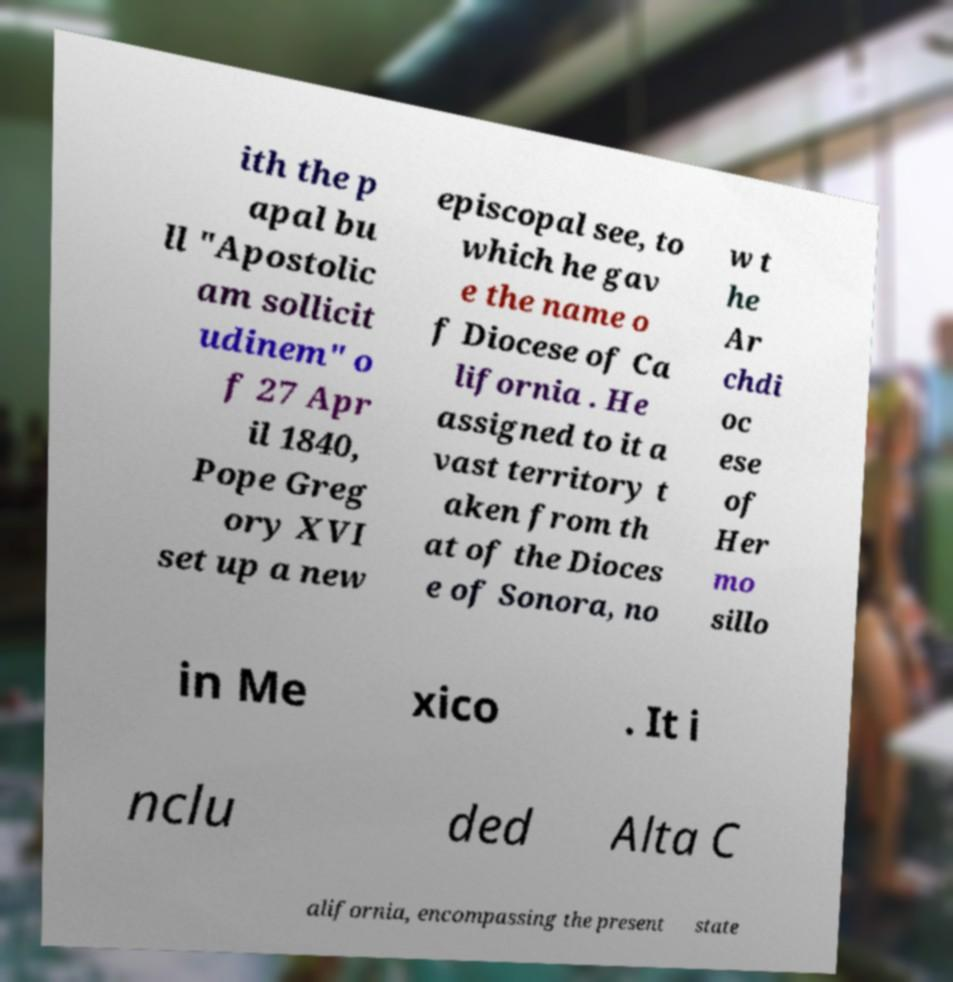Please read and relay the text visible in this image. What does it say? ith the p apal bu ll "Apostolic am sollicit udinem" o f 27 Apr il 1840, Pope Greg ory XVI set up a new episcopal see, to which he gav e the name o f Diocese of Ca lifornia . He assigned to it a vast territory t aken from th at of the Dioces e of Sonora, no w t he Ar chdi oc ese of Her mo sillo in Me xico . It i nclu ded Alta C alifornia, encompassing the present state 